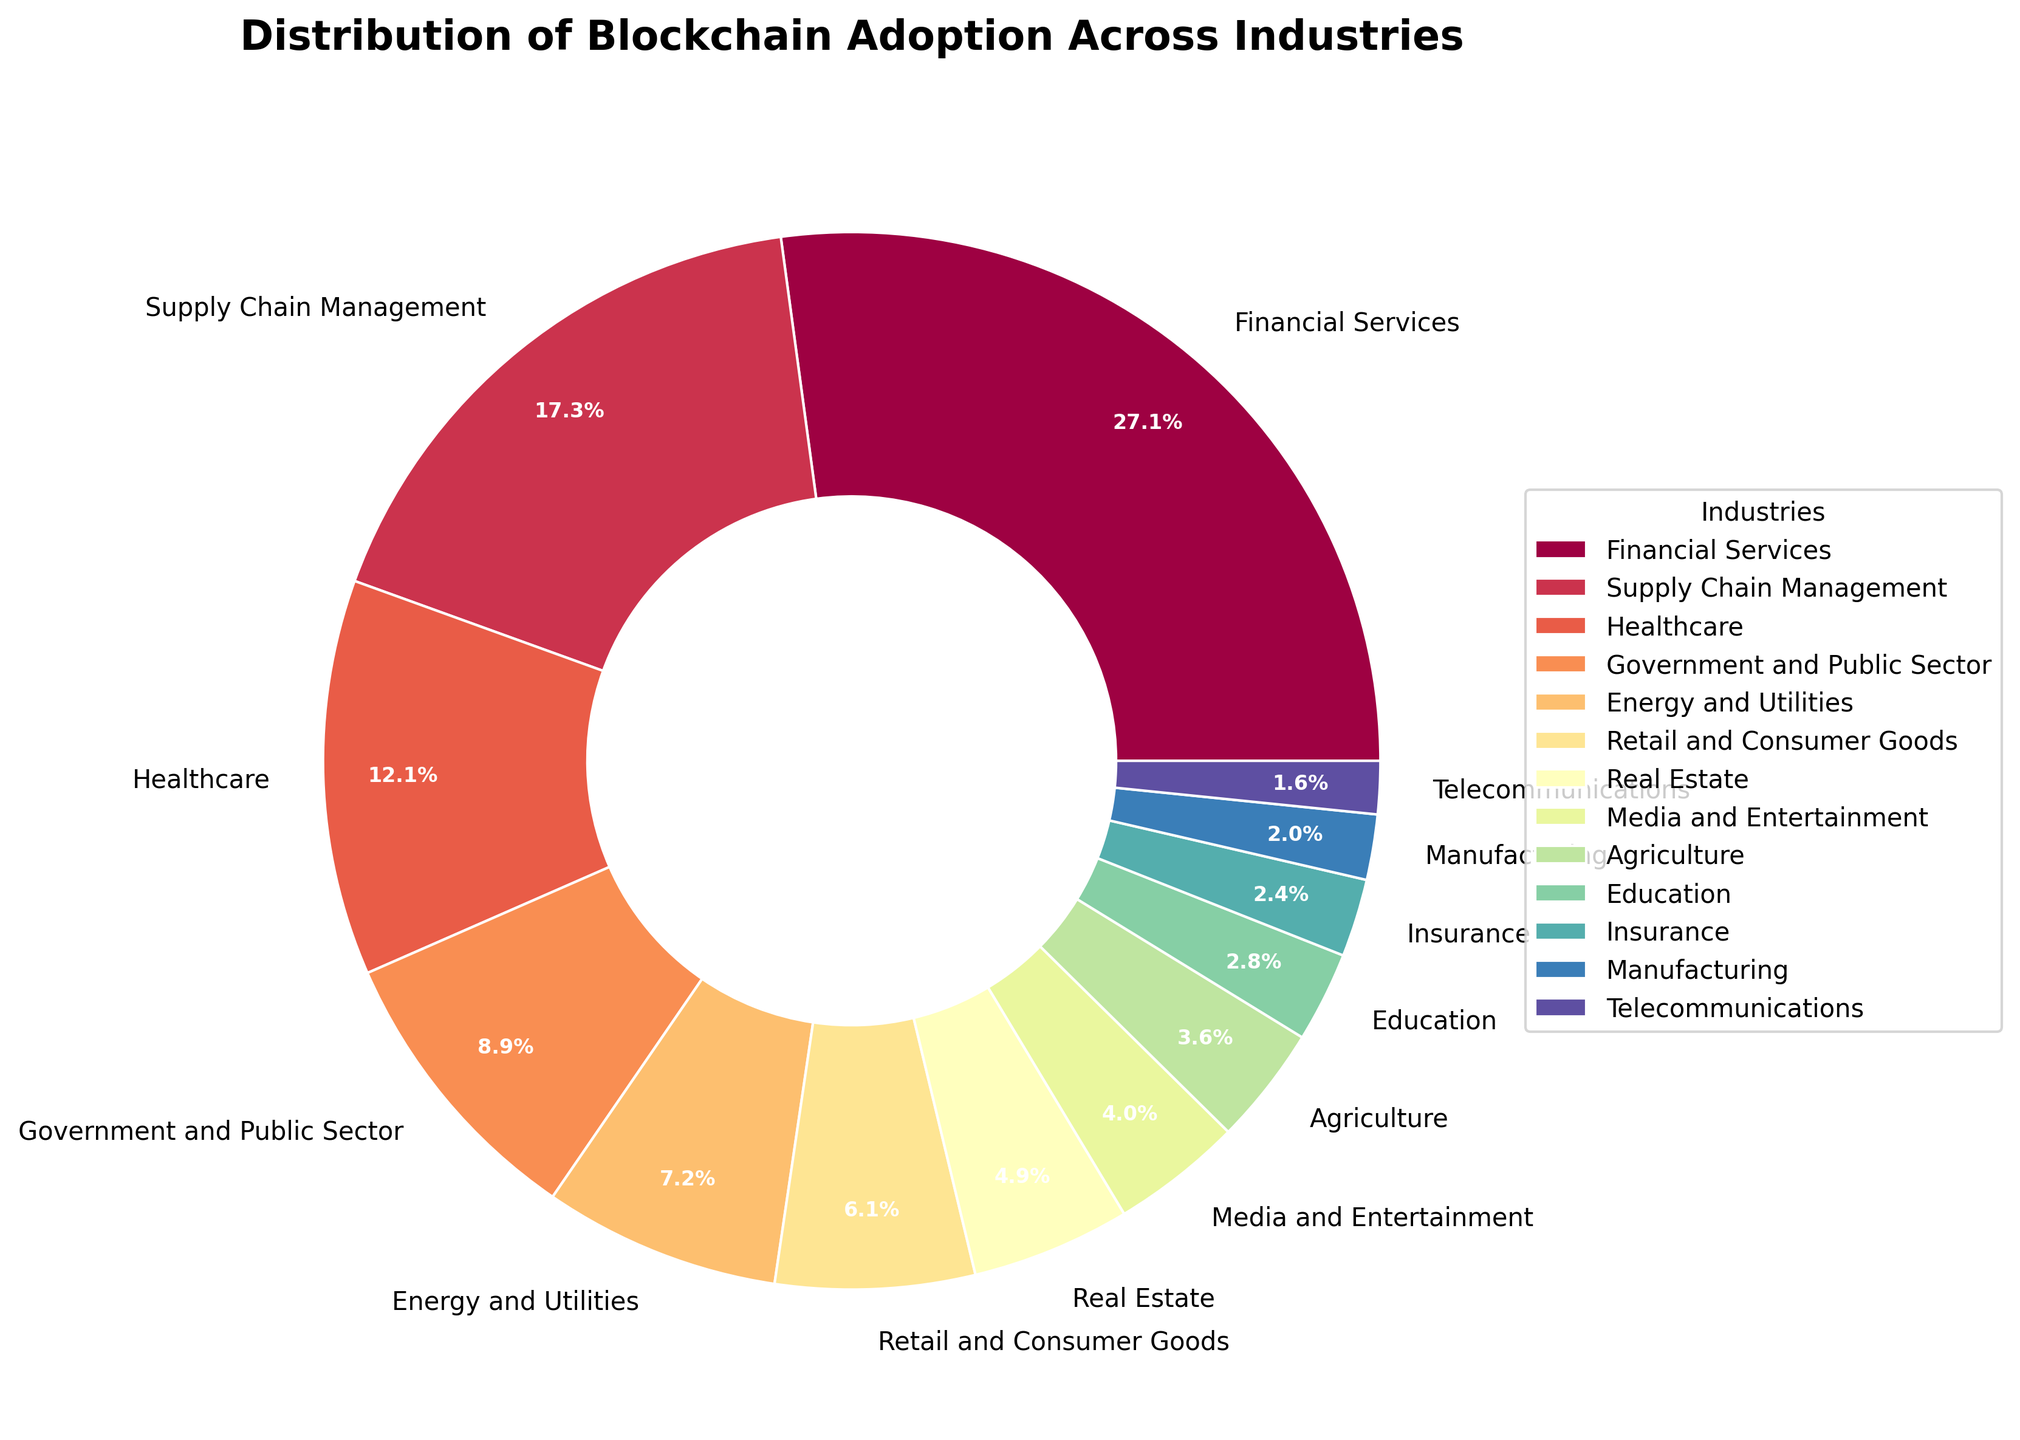What industry has the highest adoption percentage of blockchain? By looking at the pie chart, the sector with the largest slice represents the highest adoption percentage. It clearly shows the 'Financial Services' sector with the largest percentage.
Answer: Financial Services What is the combined percentage of blockchain adoption in the Healthcare and Government and Public Sector industries? To find the combined percentage, add the adoption percentages of Healthcare (12.7%) and Government and Public Sector (9.3%). The result is 12.7% + 9.3% = 22%.
Answer: 22% Which sector has a higher blockchain adoption: Retail and Consumer Goods or Real Estate? By comparing the sizes of the slices, Retail and Consumer Goods (6.4%) has a higher adoption percentage than Real Estate (5.1%).
Answer: Retail and Consumer Goods What is the difference in adoption percentage between the Supply Chain Management and Energy and Utilities sectors? To determine the difference, subtract the percentage of Energy and Utilities (7.6%) from the Supply Chain Management (18.2%). Therefore, the difference is 18.2% - 7.6% = 10.6%.
Answer: 10.6% How many industries have a blockchain adoption percentage below 5%? To answer this, identify all slices with percentages below 5%. The industries are Real Estate (5.1%), Media and Entertainment (4.2%), Agriculture (3.8%), Education (2.9%), Insurance (2.5%), Manufacturing (2.1%), and Telecommunications (1.7%). Count them and we get 7 such industries.
Answer: 7 Which sector has the smallest blockchain adoption percentage? The smallest slice on the pie chart represents the smallest percentage. In this case, Telecommunications has the smallest adoption percentage (1.7%).
Answer: Telecommunications What is the total adoption percentage of blockchain in industries that have a percentage over 10%? Sum the adoption percentages of the industries with more than 10%: Financial Services (28.5%), Supply Chain Management (18.2%), and Healthcare (12.7%). Adding these gives 28.5% + 18.2% + 12.7% = 59.4%.
Answer: 59.4% Which industry has a slightly higher adoption percentage than Media and Entertainment? By looking at the chart, Agriculture has a slightly higher percentage (3.8%) compared to Media and Entertainment (4.2%).
Answer: Agriculture Which color represents the Financial Services sector in the chart? Observing the color representing the largest slice, it is the color corresponding to Financial Services in the pie chart. The exact color description will depend on the color map used, but is prominent.
Answer: [Color description as per visual observation, e.g., red] What is the average adoption percentage of the bottom three sectors? Identify the bottom three sectors by percentage: Manufacturing (2.1%), Insurance (2.5%), and Telecommunications (1.7%). Calculate the average: (2.1% + 2.5% + 1.7%) / 3. Therefore, the average is (2.1 + 2.5 + 1.7) / 3 = 2.1%.
Answer: 2.1% 